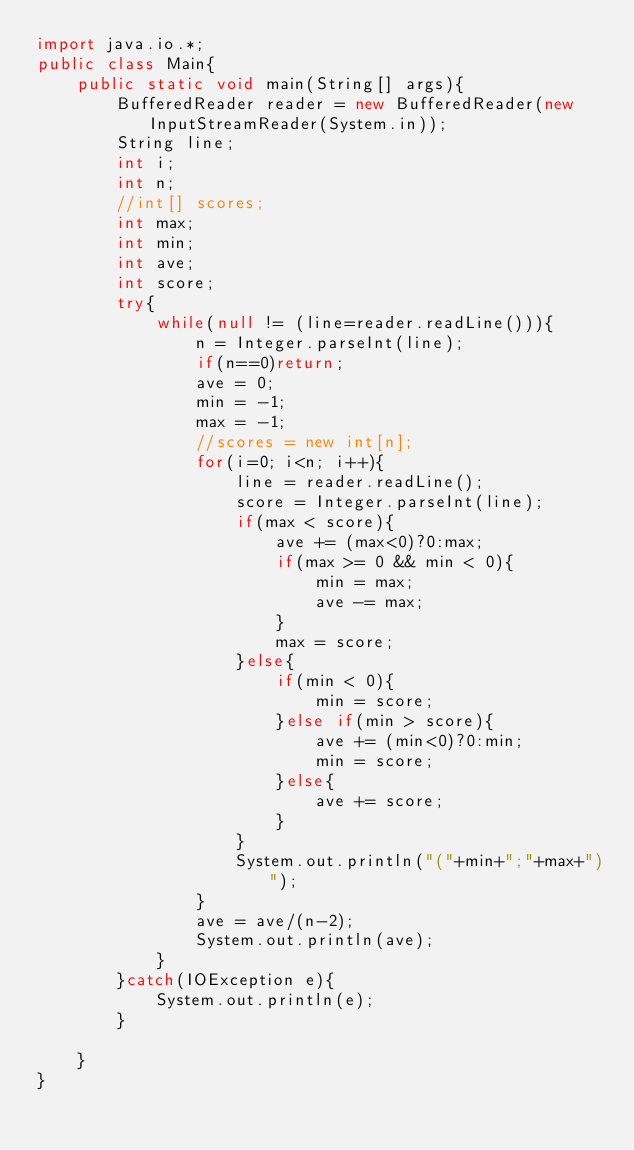<code> <loc_0><loc_0><loc_500><loc_500><_Java_>import java.io.*;
public class Main{
	public static void main(String[] args){
		BufferedReader reader = new BufferedReader(new InputStreamReader(System.in));
		String line;
		int i;
		int n;
		//int[] scores;
		int max;
		int min;
		int ave;
		int score;
		try{
			while(null != (line=reader.readLine())){
				n = Integer.parseInt(line);
				if(n==0)return;
				ave = 0;
				min = -1;
				max = -1;
				//scores = new int[n];
				for(i=0; i<n; i++){
					line = reader.readLine();
					score = Integer.parseInt(line);
					if(max < score){
						ave += (max<0)?0:max;
						if(max >= 0 && min < 0){
							min = max;
							ave -= max;
						}
						max = score;
					}else{
						if(min < 0){
							min = score;
						}else if(min > score){
							ave += (min<0)?0:min;
							min = score;
						}else{
							ave += score;
						}
					}
					System.out.println("("+min+";"+max+")");
				}
				ave = ave/(n-2);
				System.out.println(ave);
			}
		}catch(IOException e){
			System.out.println(e);
		}
		
	}
}</code> 